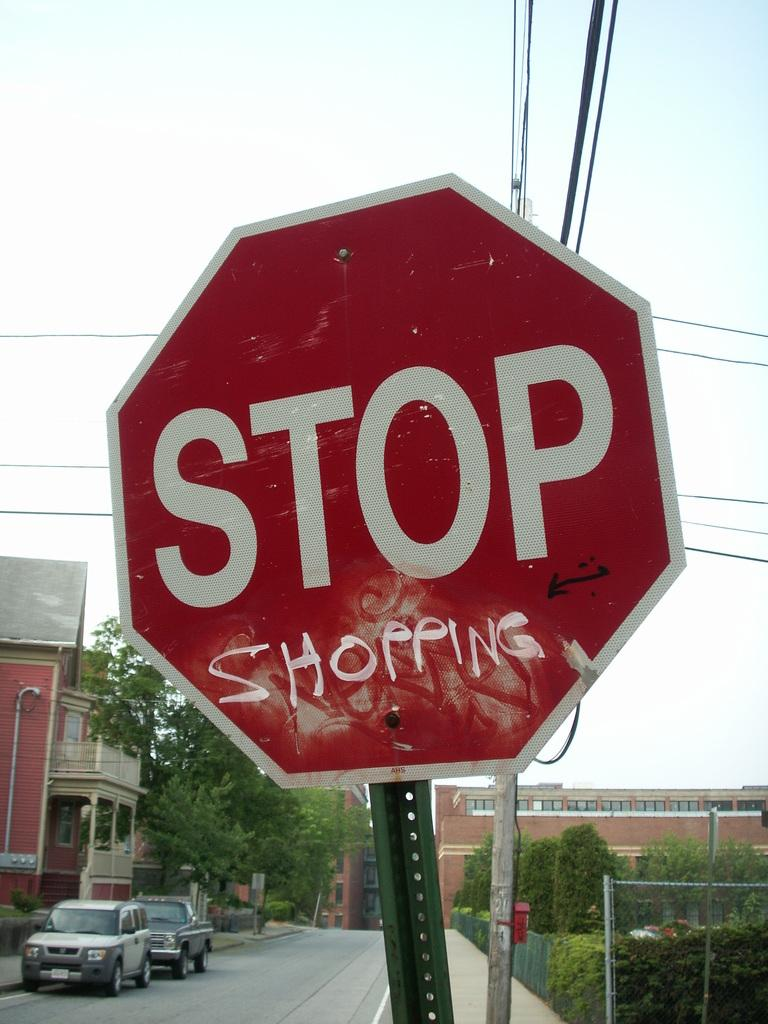What is the color of the signboard in the image? The signboard in the image is red. What can be seen attached to the signboard? There is a pole in the image. What else is present in the image along with the signboard and pole? Wires, net fencing, trees, vehicles, buildings, and the sky are visible in the image. How is the sky depicted in the image? The sky is in white and blue color. Can you see a river flowing in the image? There is no river visible in the image. 